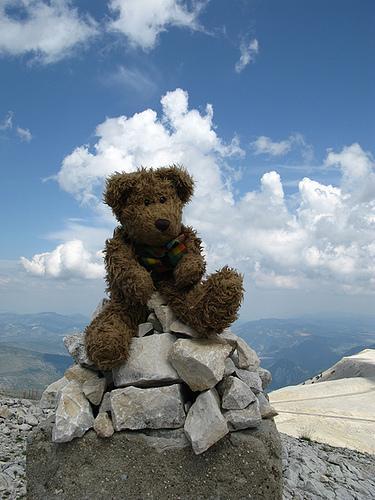How many bears are in the picture?
Give a very brief answer. 1. How many people have on glasses?
Give a very brief answer. 0. 